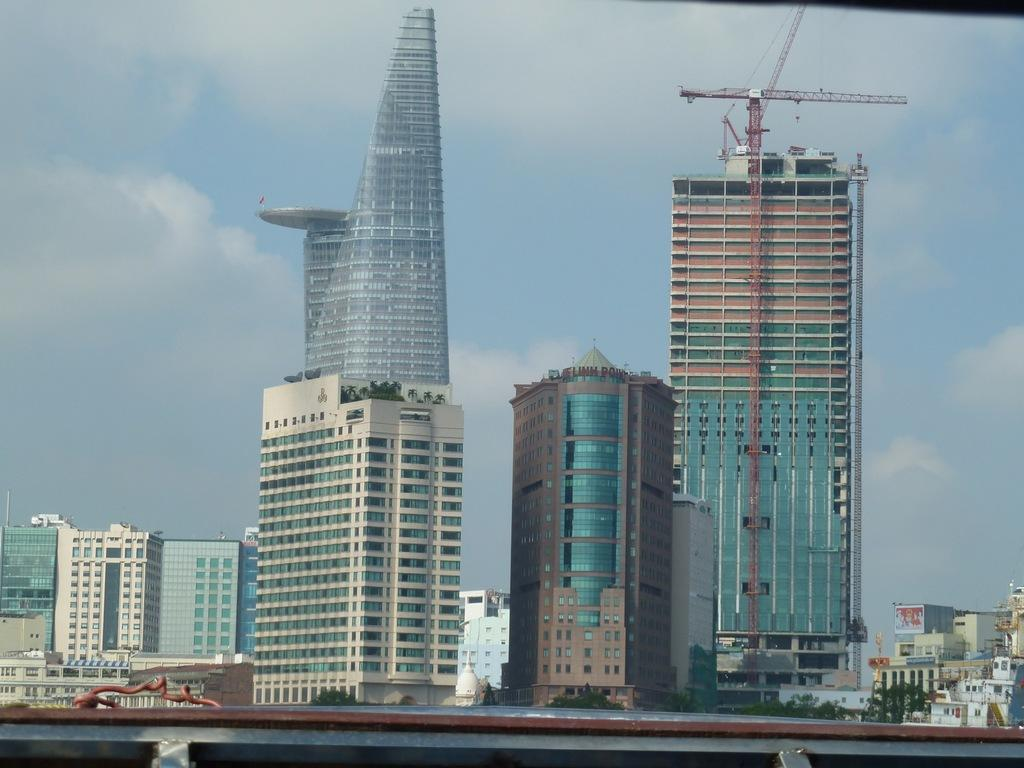What type of structures are present in the image? There are buildings with windows in the image. What piece of construction equipment can be seen in the image? There is a crane in the image. What type of vegetation is visible in the image? There are plants in the image. What can be seen in the background of the image? The sky is visible in the background of the image. Where is the cellar located in the image? There is no cellar present in the image. What type of interest does the crane have in the plants? The crane is a piece of construction equipment and does not have any interest in the plants; it is not a living being. 